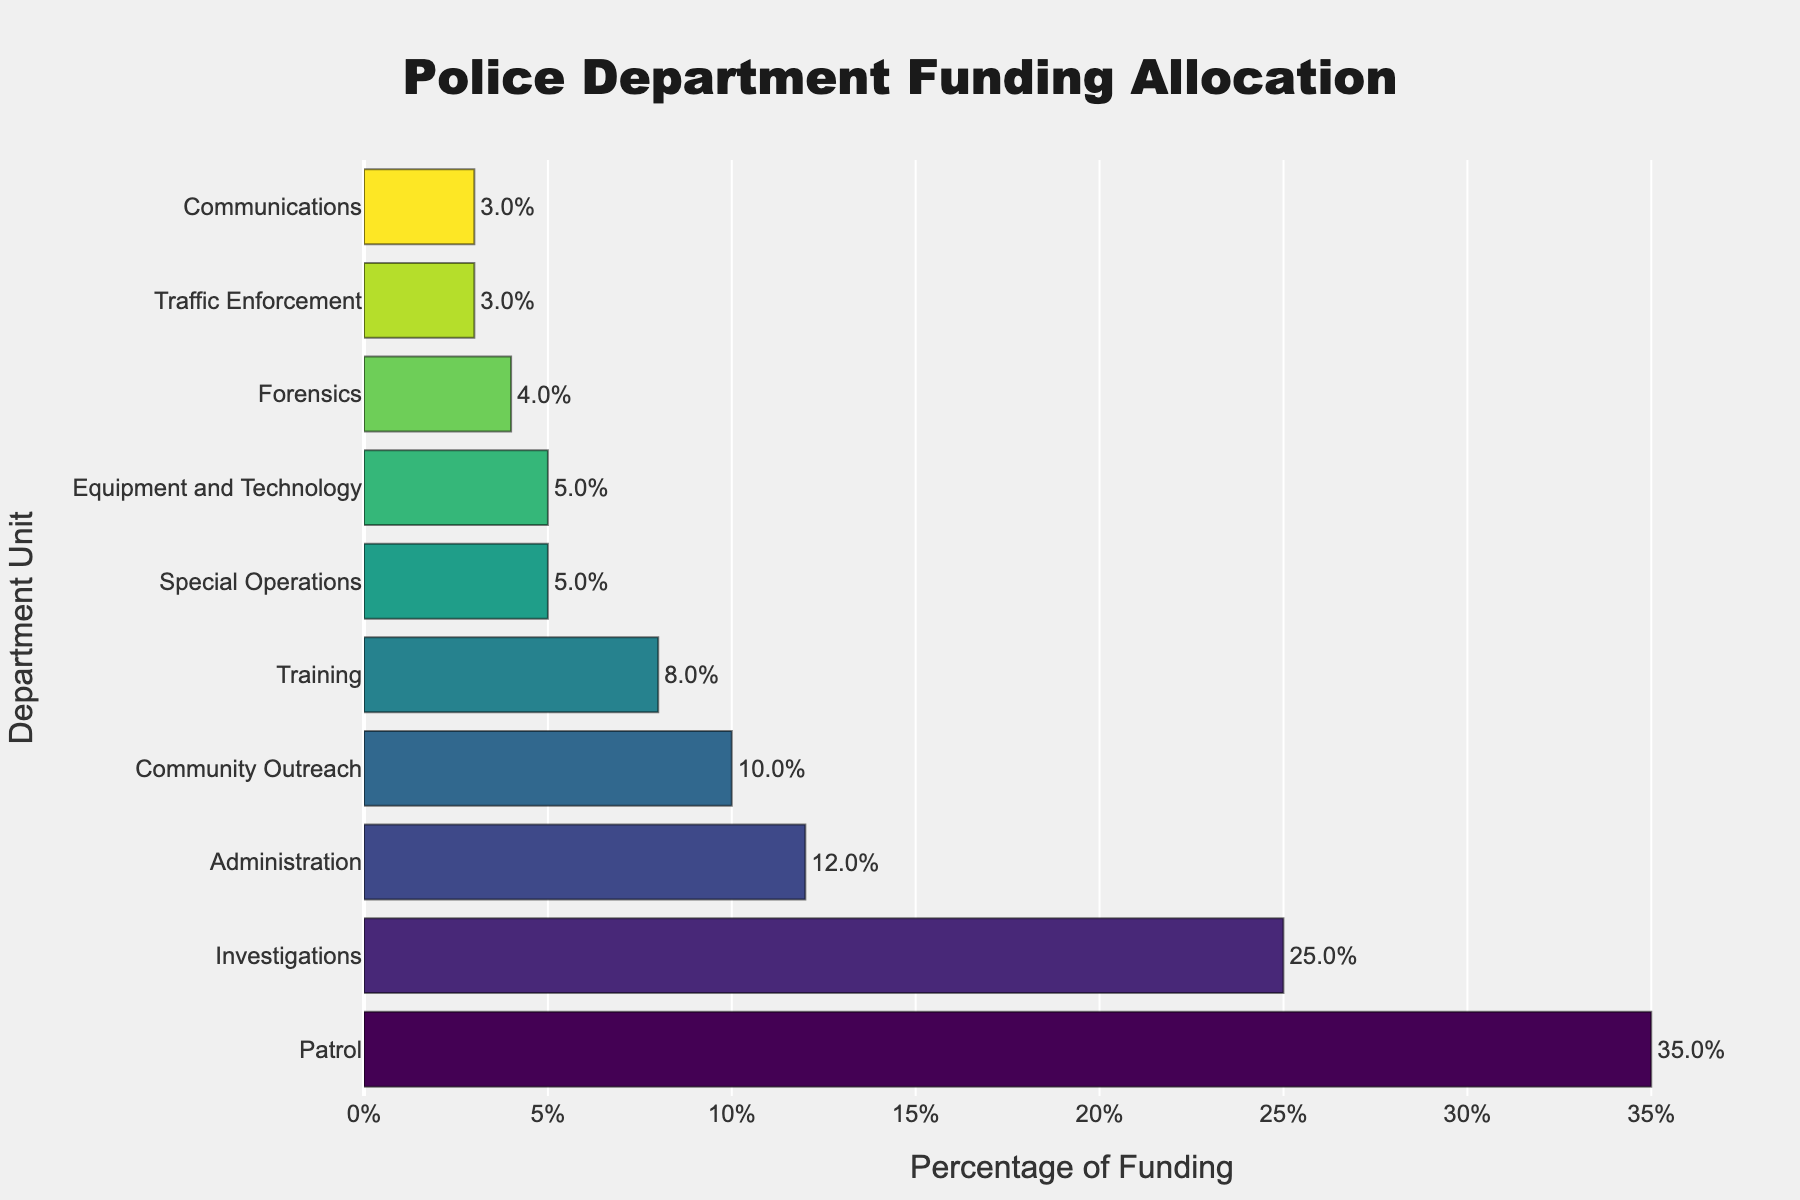what percentage of the funding is allocated to the Patrol unit? The Patrol unit has a bar extending to 35% on the horizontal axis, as indicated on the figure.
Answer: 35% how much more funding does Patrol receive compared to Investigations? The Patrol unit has 35% funding, while the Investigations unit has 25% funding. The difference is 35% - 25% = 10%.
Answer: 10% which units have less than 10% funding? Units with bars extending to less than 10% on the horizontal axis are Community Outreach (10%), Training (8%), Special Operations (5%), Traffic Enforcement (3%), Forensics (4%), Communications (3%), and Equipment and Technology (5%).
Answer: Training, Special Operations, Traffic Enforcement, Forensics, Communications, Equipment and Technology what is the total percentage of funding allocated to Administration, Training, and Special Operations combined? Add the percentages for the three units: Administration (12%), Training (8%), and Special Operations (5%). The total is 12% + 8% + 5% = 25%.
Answer: 25% is the funding for Community Outreach higher or lower than for Administration? Community Outreach has 10% funding, while Administration has 12% funding. Hence, the funding for Community Outreach is lower.
Answer: Lower what is the average percentage of funding for Traffic Enforcement, Forensics, and Communications? Add the percentages for the three units: Traffic Enforcement (3%), Forensics (4%), and Communications (3%). Then, divide by the number of units: (3% + 4% + 3%) / 3 = 10% / 3 ≈ 3.33%.
Answer: 3.33% what percentage of funding is allocated to units other than Patrol and Investigations? First, find the total funding for all units except Patrol (35%) and Investigations (25%). Total funding is 100%. Subtract Patrol and Investigations funding: 100% - 35% - 25% = 40%.
Answer: 40% which unit has the lowest funding? The bar for Traffic Enforcement extends to 3%, which is shorter than any other bar.
Answer: Traffic Enforcement are the total funding percentages for Community Outreach and Training together more or less than the funding for Investigations? Community Outreach has 10% and Training has 8%. Combined, they have 10% + 8% = 18%. Investigations have 25% funding. Hence, their combined funding is less than Investigations.
Answer: Less how much more funding does the Equipment and Technology unit receive compared to the Communications unit? Equipment and Technology have 5% funding, while Communications have 3% funding. The difference is 5% - 3% = 2%.
Answer: 2% 